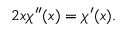Convert formula to latex. <formula><loc_0><loc_0><loc_500><loc_500>2 x \chi ^ { \prime \prime } ( x ) = \chi ^ { \prime } ( x ) .</formula> 